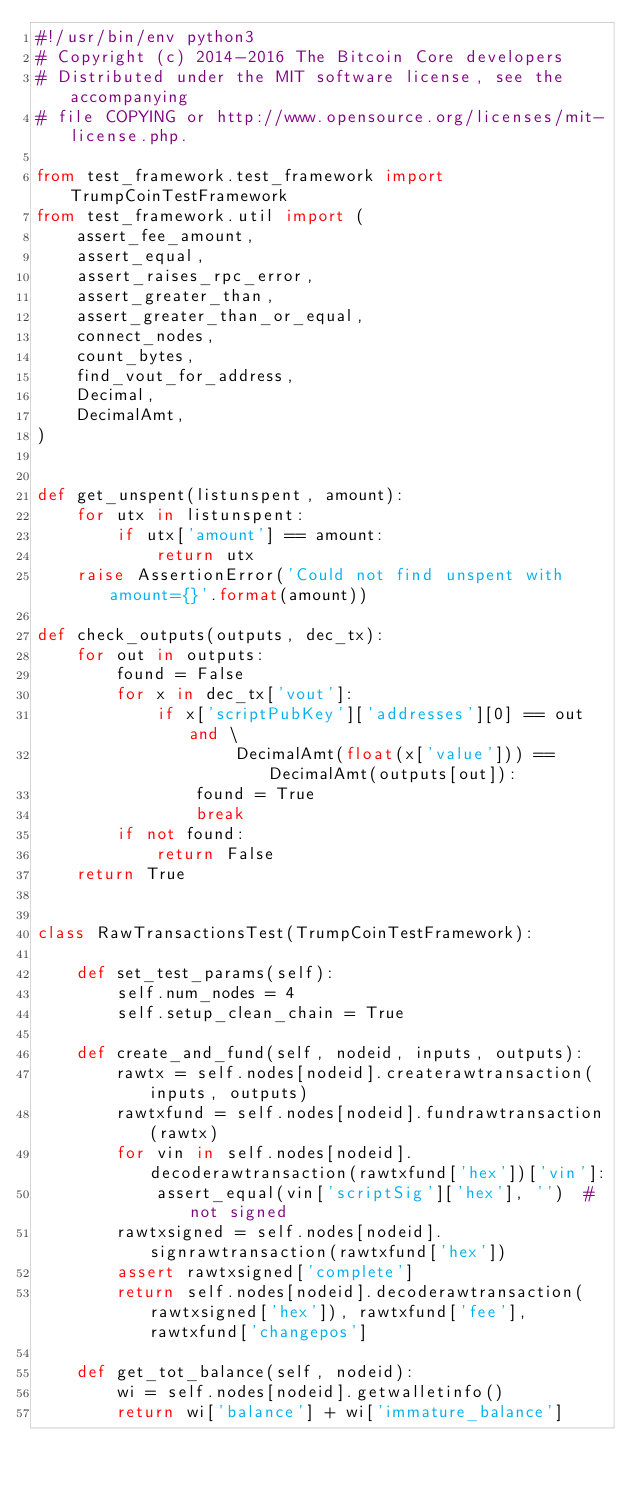Convert code to text. <code><loc_0><loc_0><loc_500><loc_500><_Python_>#!/usr/bin/env python3
# Copyright (c) 2014-2016 The Bitcoin Core developers
# Distributed under the MIT software license, see the accompanying
# file COPYING or http://www.opensource.org/licenses/mit-license.php.

from test_framework.test_framework import TrumpCoinTestFramework
from test_framework.util import (
    assert_fee_amount,
    assert_equal,
    assert_raises_rpc_error,
    assert_greater_than,
    assert_greater_than_or_equal,
    connect_nodes,
    count_bytes,
    find_vout_for_address,
    Decimal,
    DecimalAmt,
)


def get_unspent(listunspent, amount):
    for utx in listunspent:
        if utx['amount'] == amount:
            return utx
    raise AssertionError('Could not find unspent with amount={}'.format(amount))

def check_outputs(outputs, dec_tx):
    for out in outputs:
        found = False
        for x in dec_tx['vout']:
            if x['scriptPubKey']['addresses'][0] == out and \
                    DecimalAmt(float(x['value'])) == DecimalAmt(outputs[out]):
                found = True
                break
        if not found:
            return False
    return True


class RawTransactionsTest(TrumpCoinTestFramework):

    def set_test_params(self):
        self.num_nodes = 4
        self.setup_clean_chain = True

    def create_and_fund(self, nodeid, inputs, outputs):
        rawtx = self.nodes[nodeid].createrawtransaction(inputs, outputs)
        rawtxfund = self.nodes[nodeid].fundrawtransaction(rawtx)
        for vin in self.nodes[nodeid].decoderawtransaction(rawtxfund['hex'])['vin']:
            assert_equal(vin['scriptSig']['hex'], '')  # not signed
        rawtxsigned = self.nodes[nodeid].signrawtransaction(rawtxfund['hex'])
        assert rawtxsigned['complete']
        return self.nodes[nodeid].decoderawtransaction(rawtxsigned['hex']), rawtxfund['fee'], rawtxfund['changepos']

    def get_tot_balance(self, nodeid):
        wi = self.nodes[nodeid].getwalletinfo()
        return wi['balance'] + wi['immature_balance']
</code> 